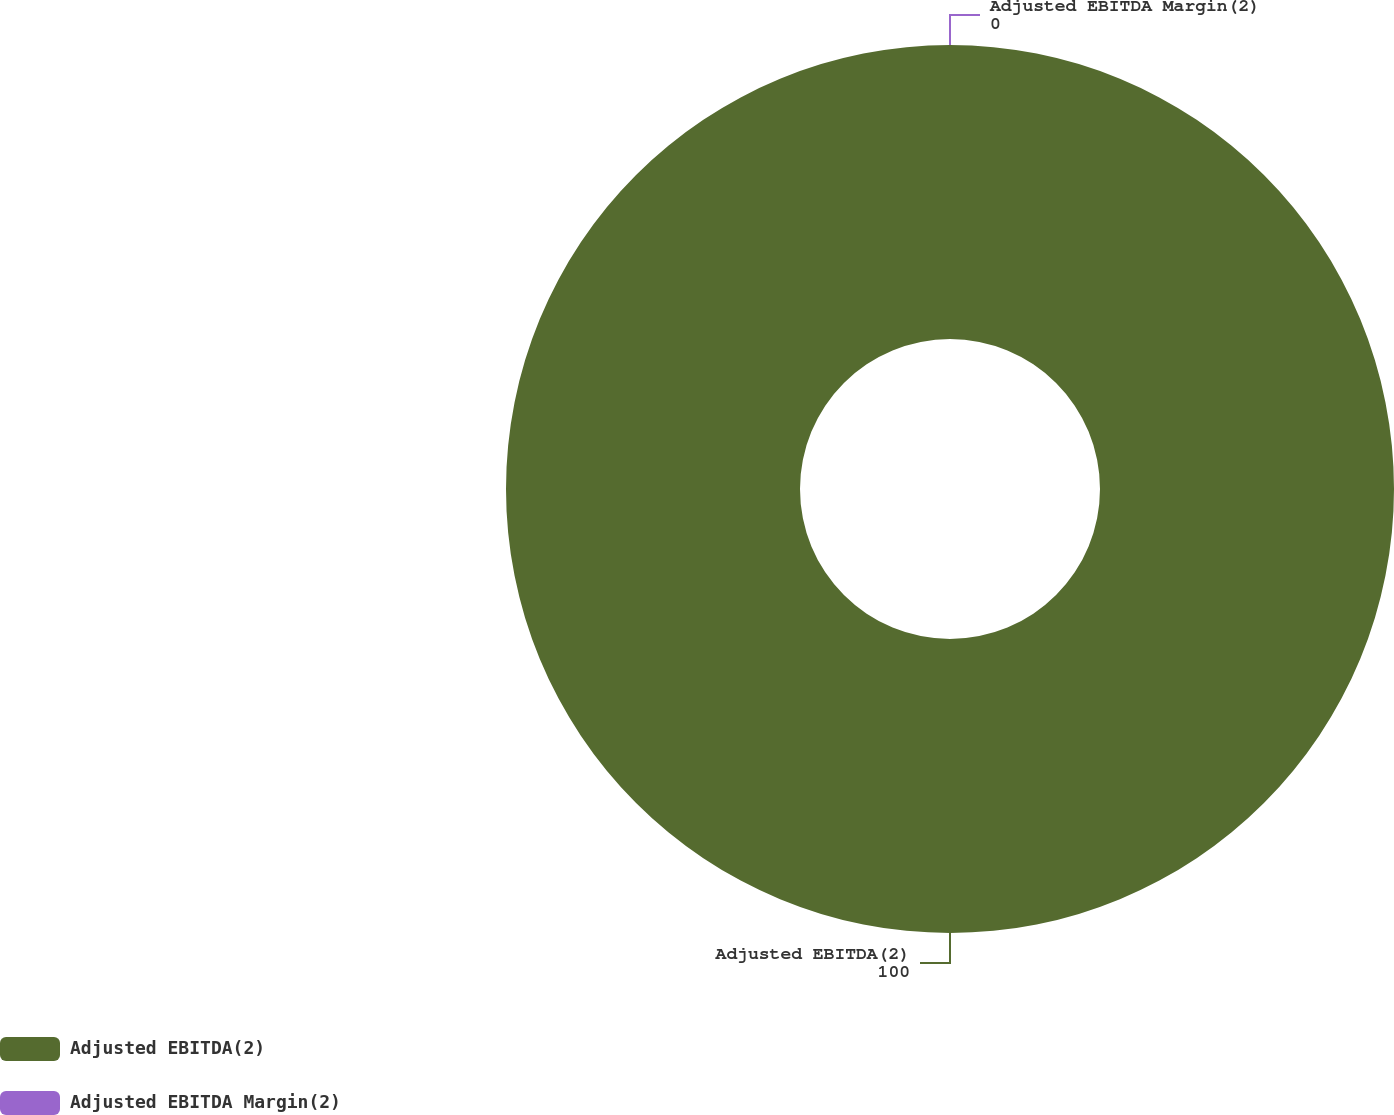Convert chart. <chart><loc_0><loc_0><loc_500><loc_500><pie_chart><fcel>Adjusted EBITDA(2)<fcel>Adjusted EBITDA Margin(2)<nl><fcel>100.0%<fcel>0.0%<nl></chart> 